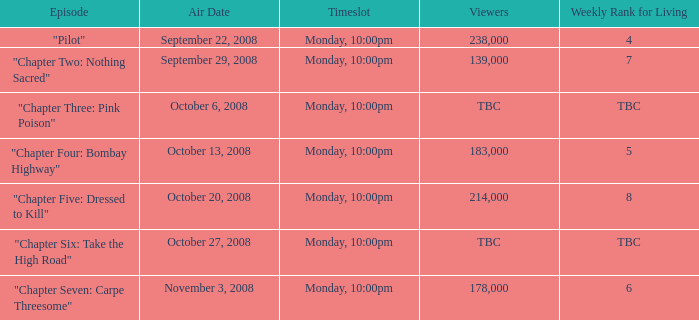How many viewers for the episode with the weekly rank for living of 4? 238000.0. 